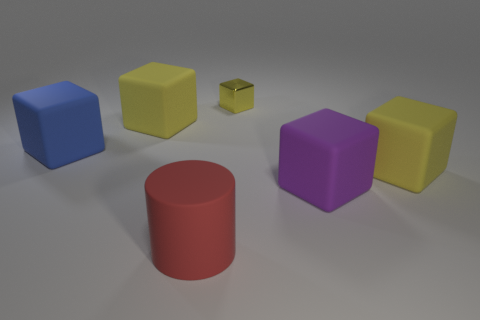Subtract all red cylinders. How many yellow blocks are left? 3 Subtract 1 blocks. How many blocks are left? 4 Subtract all blue cubes. How many cubes are left? 4 Add 2 red matte objects. How many objects exist? 8 Subtract all purple cylinders. Subtract all purple cubes. How many cylinders are left? 1 Subtract all cylinders. How many objects are left? 5 Add 2 yellow cubes. How many yellow cubes are left? 5 Add 1 tiny blue metal cubes. How many tiny blue metal cubes exist? 1 Subtract 0 yellow spheres. How many objects are left? 6 Subtract all red cylinders. Subtract all cyan rubber things. How many objects are left? 5 